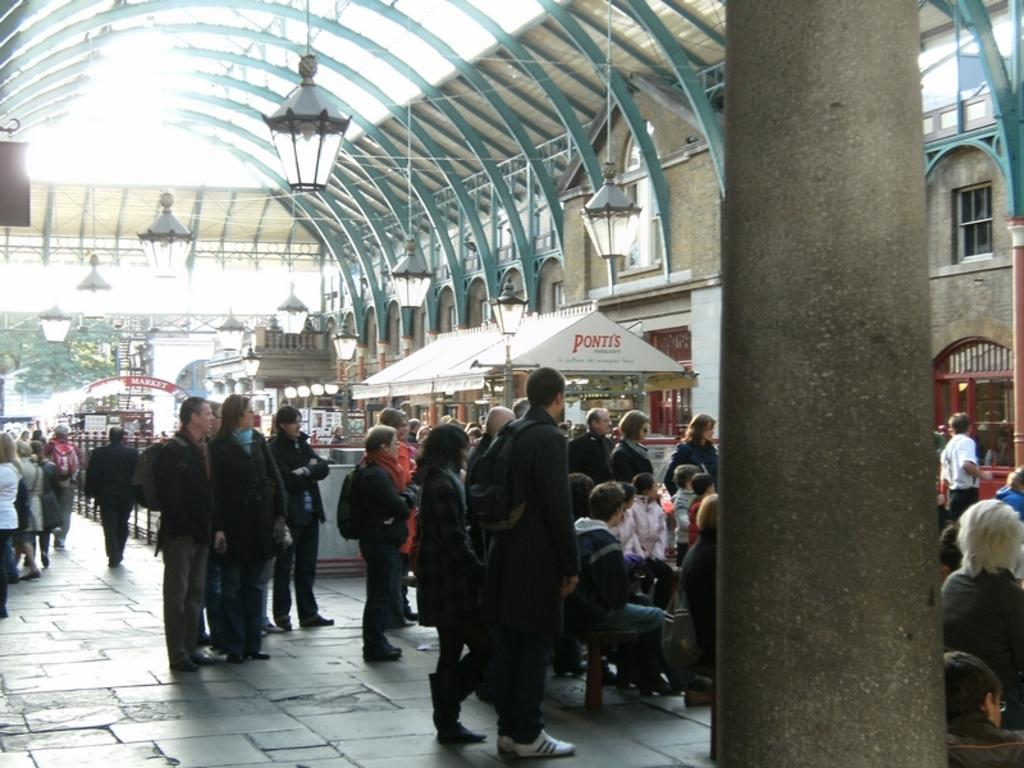Provide a one-sentence caption for the provided image. People standing by a white canopy with red lettering of Ponti's on it. 